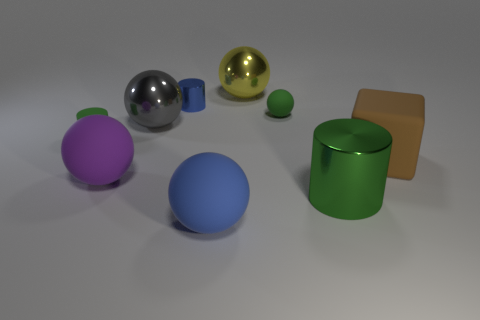Subtract 2 spheres. How many spheres are left? 3 Subtract all blue spheres. How many spheres are left? 4 Subtract all red balls. Subtract all gray blocks. How many balls are left? 5 Add 1 tiny gray balls. How many objects exist? 10 Subtract all cylinders. How many objects are left? 6 Subtract 0 brown cylinders. How many objects are left? 9 Subtract all large yellow balls. Subtract all large gray metal things. How many objects are left? 7 Add 4 spheres. How many spheres are left? 9 Add 4 metal things. How many metal things exist? 8 